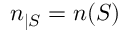<formula> <loc_0><loc_0><loc_500><loc_500>n _ { | S } = n ( S )</formula> 